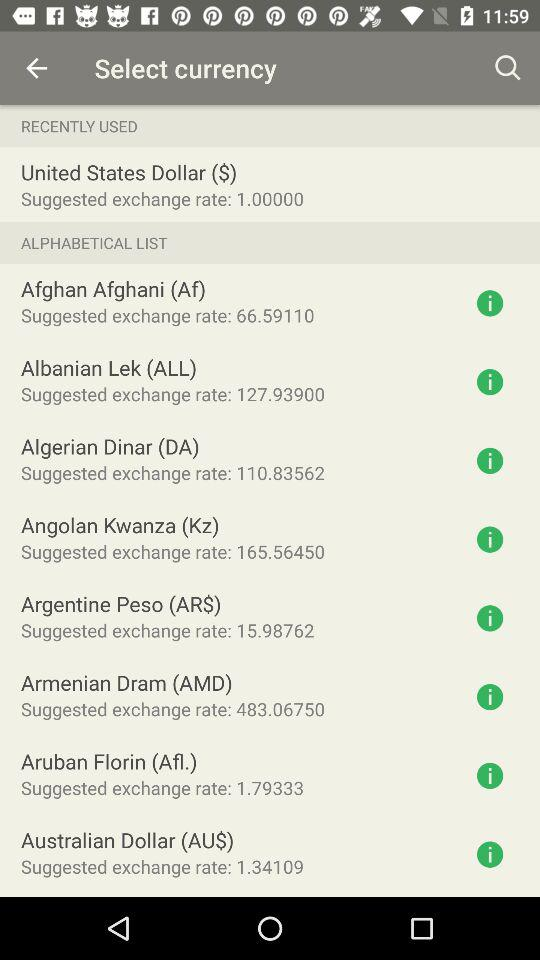Which currency has been recently used? The currency that has been recently used is the United States dollar. 